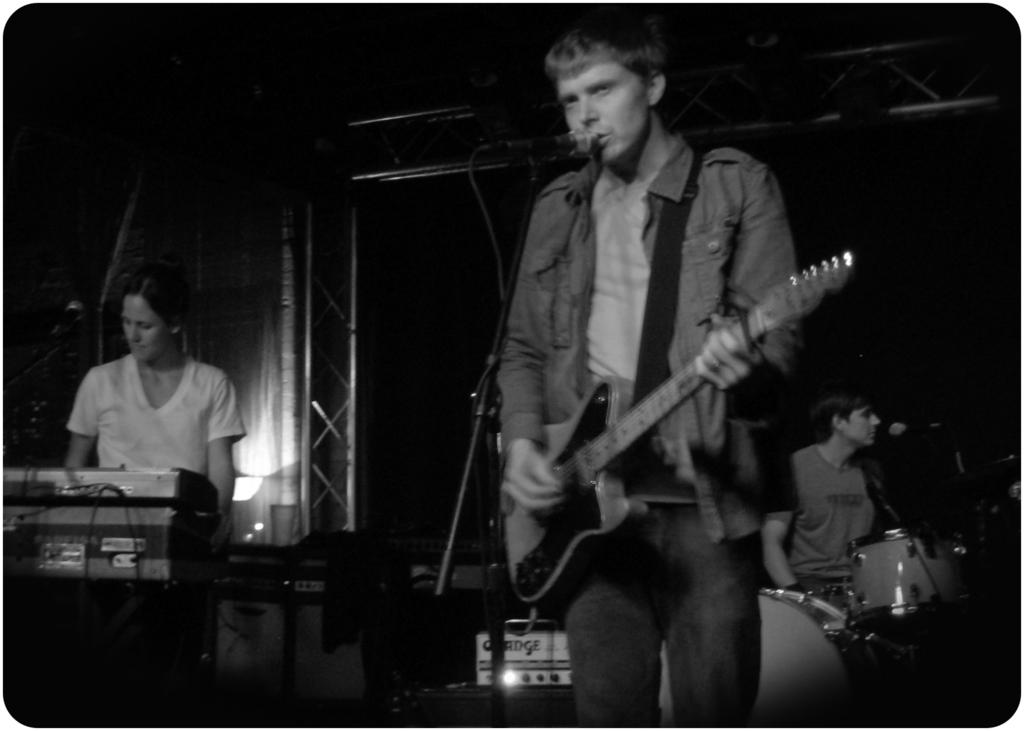How many people are in the image? There are two men and a woman in the image, making a total of three individuals. What are the people in the image doing? All three individuals are holding musical instruments. Can you describe any equipment related to sound or performance in the image? Yes, there is a microphone (mic) visible in the image. What type of cable can be seen connecting the instruments in the image? There is no cable connecting the instruments visible in the image. Can you describe the growth of the plants in the image? There are no plants present in the image. 